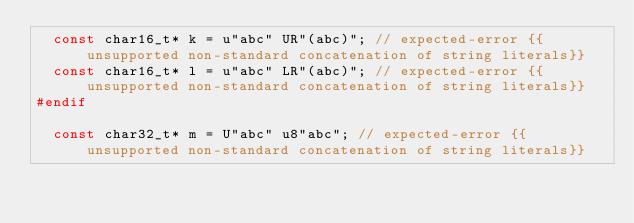Convert code to text. <code><loc_0><loc_0><loc_500><loc_500><_C++_>  const char16_t* k = u"abc" UR"(abc)"; // expected-error {{unsupported non-standard concatenation of string literals}}
  const char16_t* l = u"abc" LR"(abc)"; // expected-error {{unsupported non-standard concatenation of string literals}}
#endif

  const char32_t* m = U"abc" u8"abc"; // expected-error {{unsupported non-standard concatenation of string literals}}</code> 